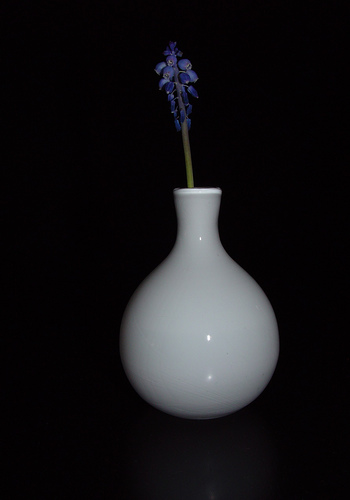Can you describe the vase in the image? The vase in the image is sleek and elegantly shaped with a smooth, white finish. It has a bulbous base tapering to a narrow neck, ideal for holding a single stem or a small arrangement, adding a minimalist but sophisticated touch to its presentation. 